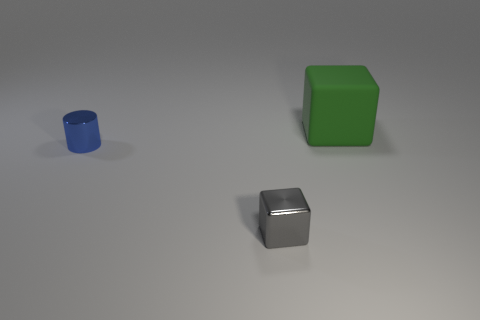Add 1 small cyan shiny cylinders. How many objects exist? 4 Subtract all cubes. How many objects are left? 1 Add 1 blue metallic cylinders. How many blue metallic cylinders are left? 2 Add 2 green things. How many green things exist? 3 Subtract 1 green cubes. How many objects are left? 2 Subtract all small shiny blocks. Subtract all tiny gray blocks. How many objects are left? 1 